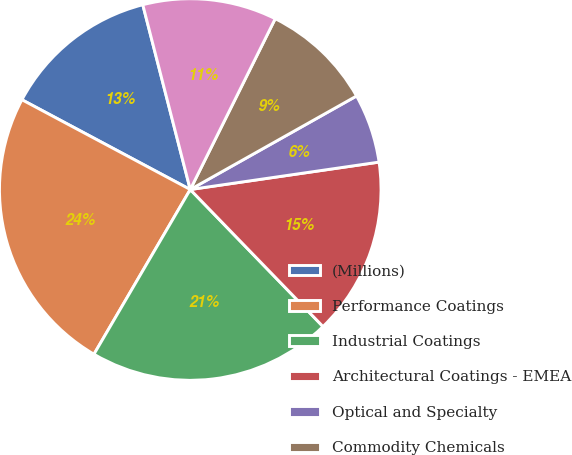Convert chart to OTSL. <chart><loc_0><loc_0><loc_500><loc_500><pie_chart><fcel>(Millions)<fcel>Performance Coatings<fcel>Industrial Coatings<fcel>Architectural Coatings - EMEA<fcel>Optical and Specialty<fcel>Commodity Chemicals<fcel>Glass<nl><fcel>13.2%<fcel>24.38%<fcel>20.67%<fcel>15.05%<fcel>5.86%<fcel>9.5%<fcel>11.35%<nl></chart> 